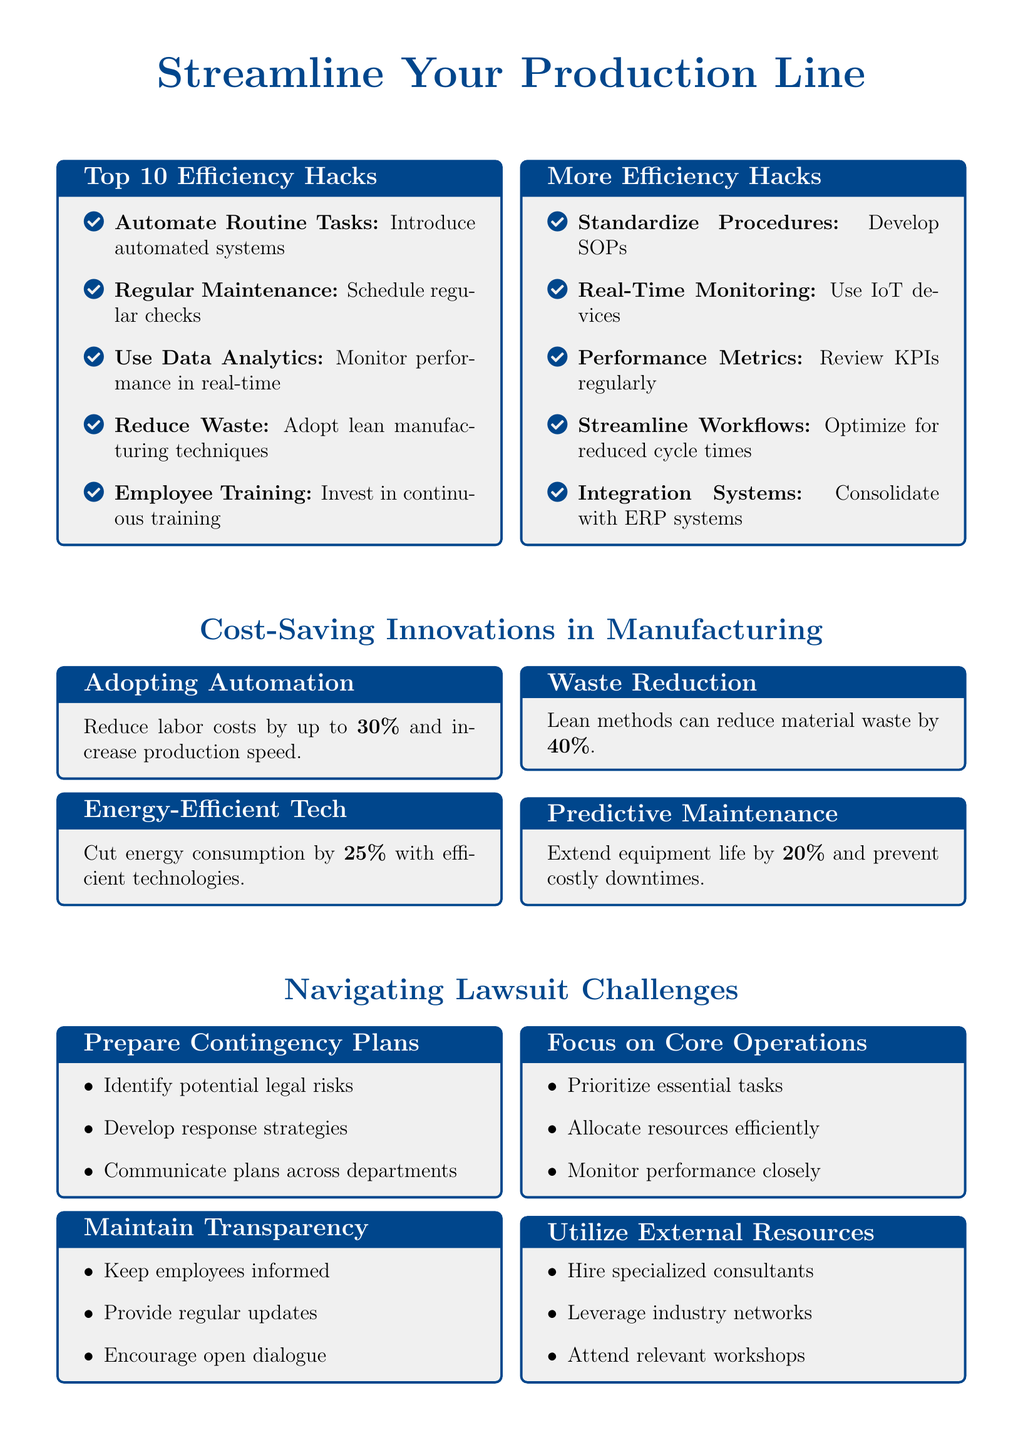What are the top items listed for efficiency hacks? The top items listed are methods to improve operational efficiency in production management.
Answer: Automate Routine Tasks, Regular Maintenance, Use Data Analytics, Reduce Waste, Employee Training, Standardize Procedures, Real-Time Monitoring, Performance Metrics, Streamline Workflows, Integration Systems What percentage can lean methods reduce material waste by? This percentage is highlighted in the document as part of the cost-saving innovations in manufacturing.
Answer: 40% What is one benefit of adopting automation mentioned in the flyer? This benefit is related to labor costs and production speed.
Answer: Reduce labor costs by up to 30% How many efficiency hacks are mentioned in the flyer? The total number of efficiency hacks is a key value presented in the document.
Answer: 10 What is a suggested strategy for maintaining transparency during a lawsuit? This strategy is about keeping the workforce informed about legal challenges.
Answer: Keep employees informed How can predictive maintenance benefit manufacturing? This benefit focuses on the lifespan and operational continuity of equipment.
Answer: Extend equipment life by 20% What type of document is this? The nature of the document is reflected by its content and layout specific to production management.
Answer: Flyer What item suggests to utilize external resources? This item relates to hiring experts and networking for legal support.
Answer: Hire specialized consultants 